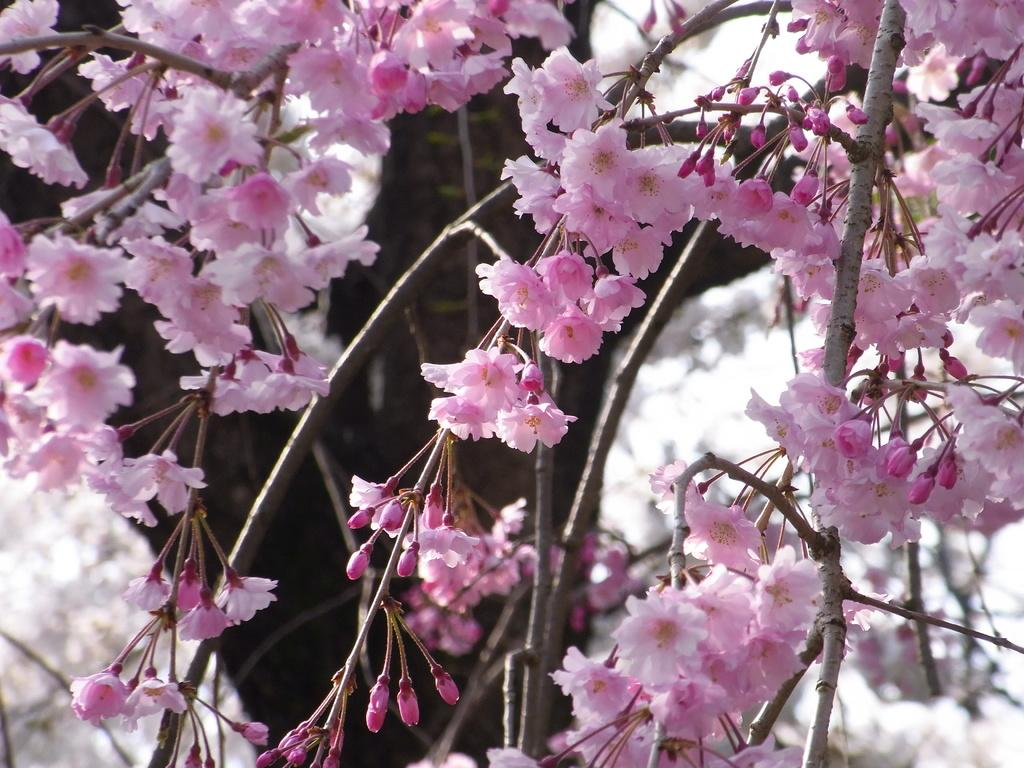What type of flowers are present in the image? There are cherry blossoms in the image. Can you see any toothbrushes in the image? There are no toothbrushes present in the image; it features cherry blossoms. Is there a fire visible in the image? There is no fire visible in the image; it features cherry blossoms. 